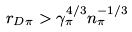<formula> <loc_0><loc_0><loc_500><loc_500>r _ { D \pi } > \gamma _ { \pi } ^ { 4 / 3 } n _ { \pi } ^ { - 1 / 3 }</formula> 